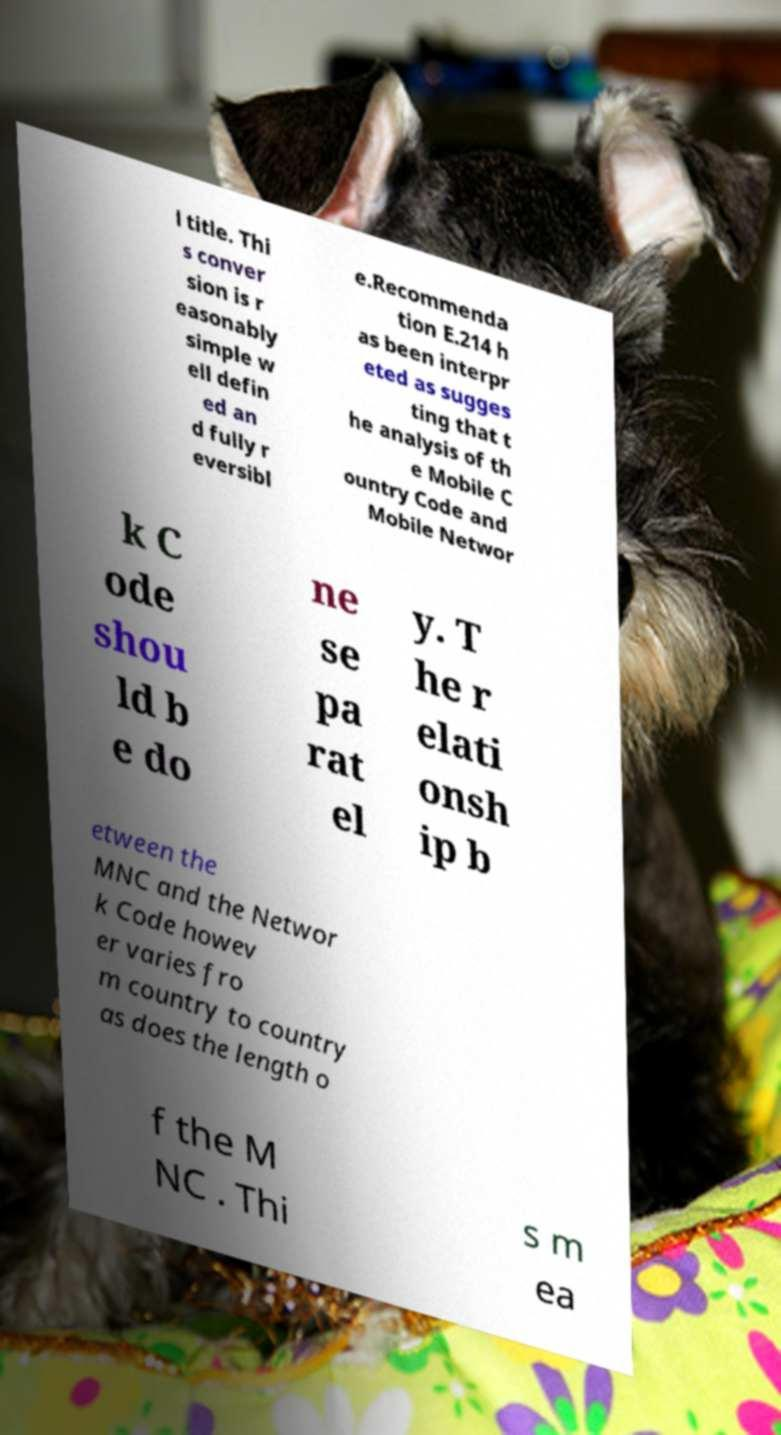For documentation purposes, I need the text within this image transcribed. Could you provide that? l title. Thi s conver sion is r easonably simple w ell defin ed an d fully r eversibl e.Recommenda tion E.214 h as been interpr eted as sugges ting that t he analysis of th e Mobile C ountry Code and Mobile Networ k C ode shou ld b e do ne se pa rat el y. T he r elati onsh ip b etween the MNC and the Networ k Code howev er varies fro m country to country as does the length o f the M NC . Thi s m ea 